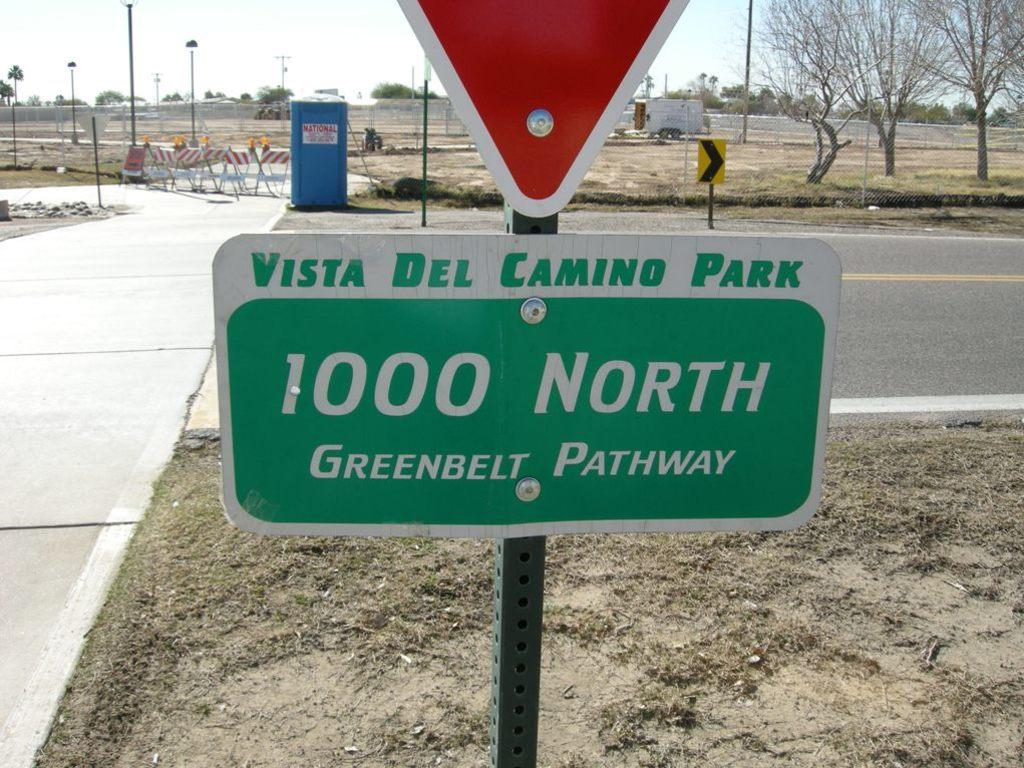<image>
Create a compact narrative representing the image presented. A sign for Vista Del Camino Park at 1000 North Greenbelt Pathway. 